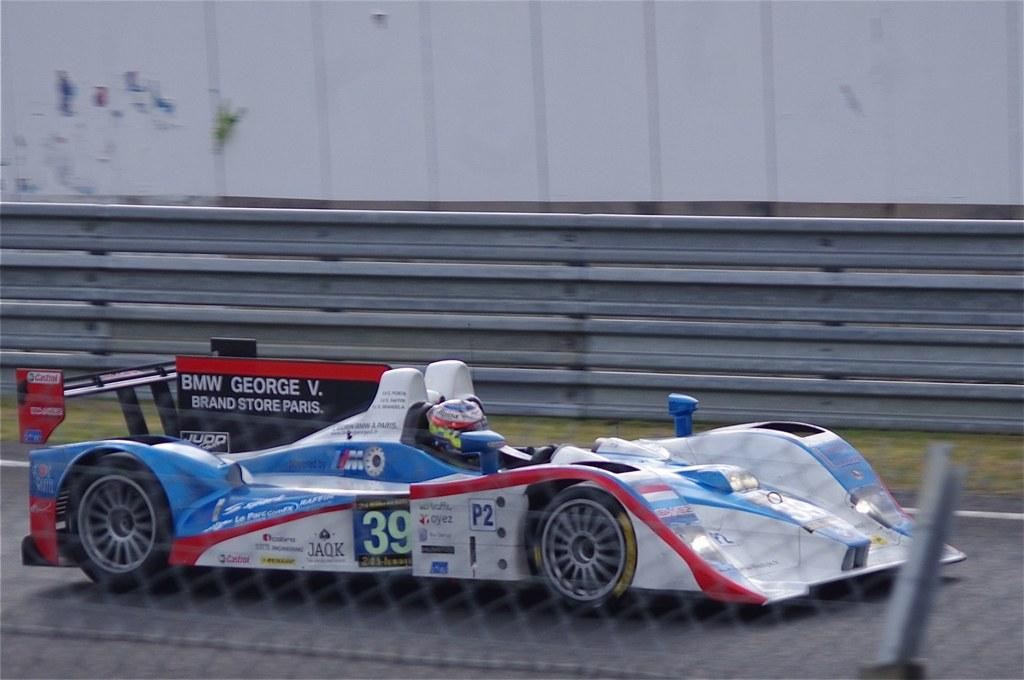What is the person in the image doing? The person is driving a car in the image. Where is the car located? The car is on the road in the image. What can be seen near the road in the image? There is a fence with a pole and green grass on the side of the road in the image. What is the color and size of the wall in the image? There is a big white wall in the image. What object is present on the surface in the image? There is an object on the surface in the image, but its description is not provided in the facts. What type of eggnog is being consumed by the person driving the car in the image? There is no mention of eggnog in the image, and the person driving the car is not consuming anything. How many feet are visible in the image? The image does not show any feet; it only shows a person driving a car, a car on the road, a fence with a pole, green grass, a big white wall, and an object on the surface. 